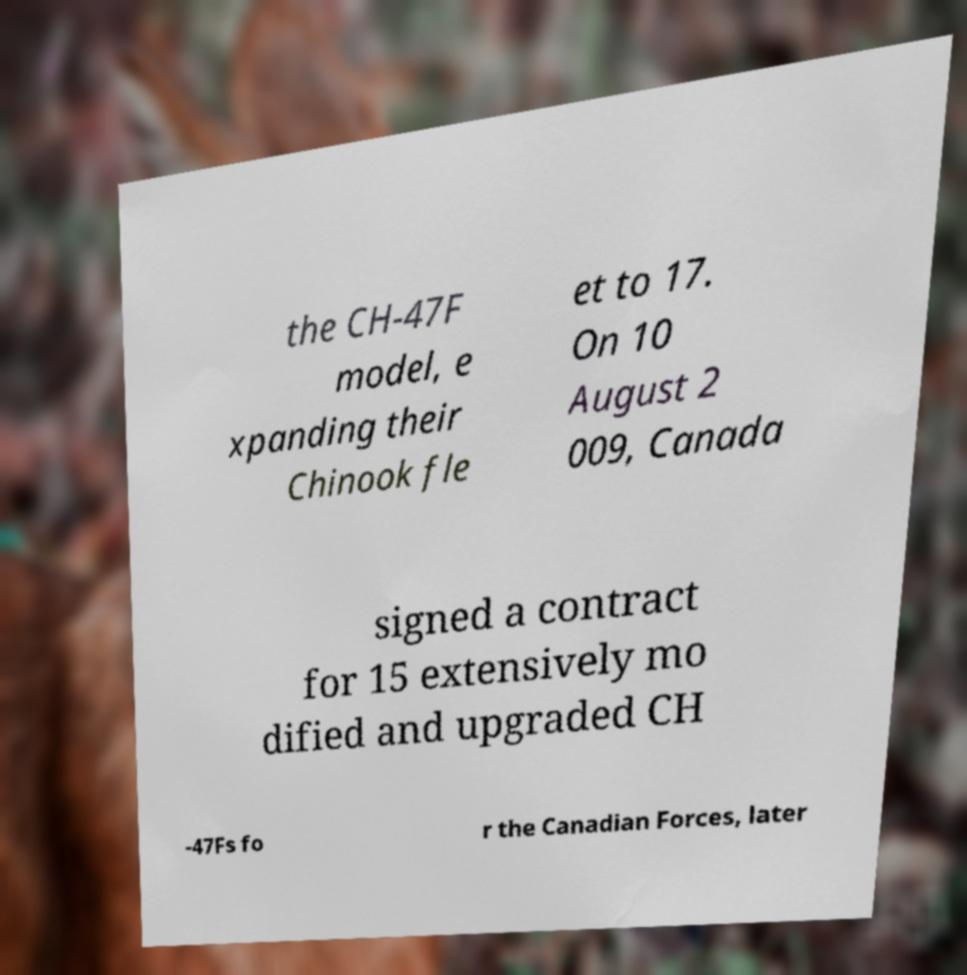For documentation purposes, I need the text within this image transcribed. Could you provide that? the CH-47F model, e xpanding their Chinook fle et to 17. On 10 August 2 009, Canada signed a contract for 15 extensively mo dified and upgraded CH -47Fs fo r the Canadian Forces, later 